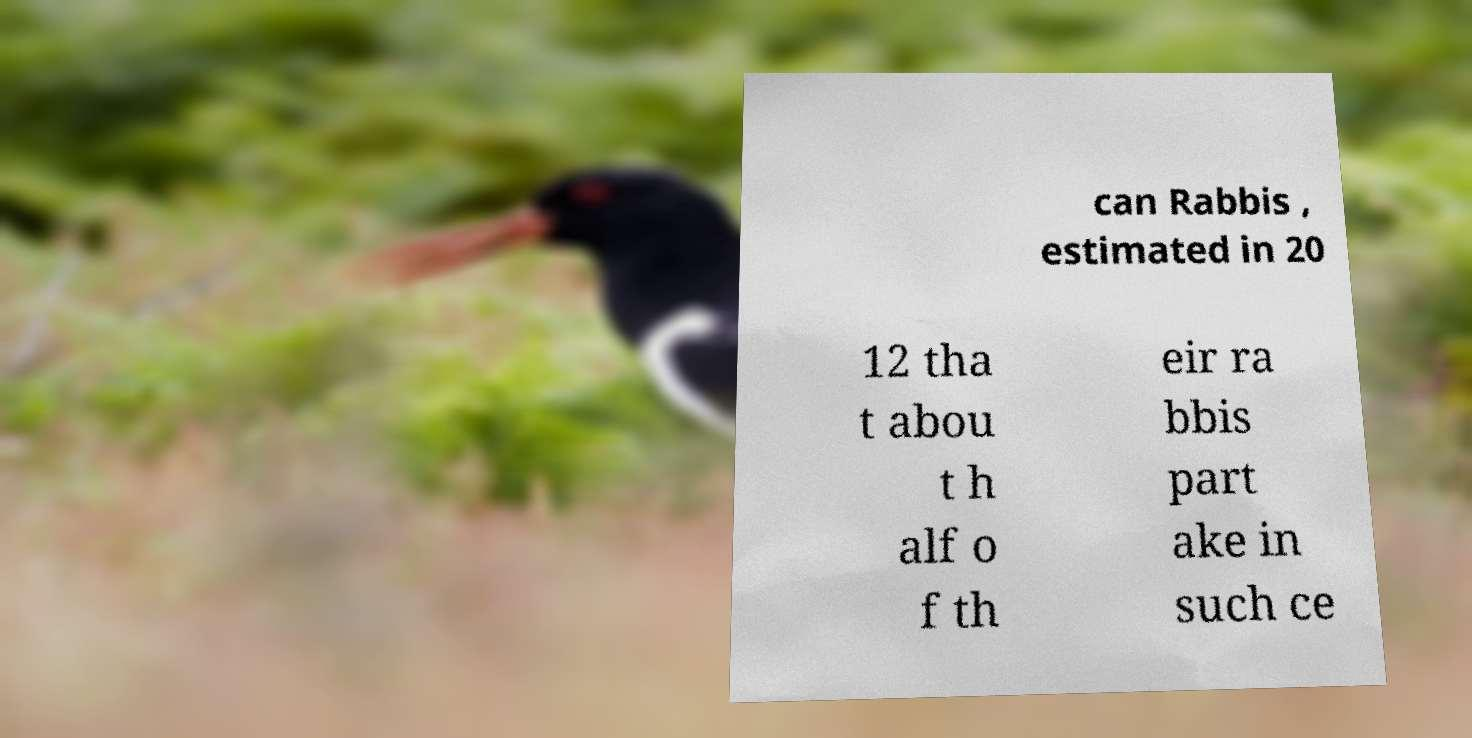For documentation purposes, I need the text within this image transcribed. Could you provide that? can Rabbis , estimated in 20 12 tha t abou t h alf o f th eir ra bbis part ake in such ce 